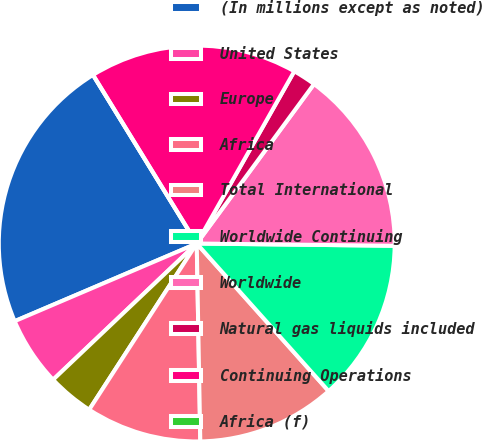<chart> <loc_0><loc_0><loc_500><loc_500><pie_chart><fcel>(In millions except as noted)<fcel>United States<fcel>Europe<fcel>Africa<fcel>Total International<fcel>Worldwide Continuing<fcel>Worldwide<fcel>Natural gas liquids included<fcel>Continuing Operations<fcel>Africa (f)<nl><fcel>22.64%<fcel>5.66%<fcel>3.78%<fcel>9.43%<fcel>11.32%<fcel>13.21%<fcel>15.09%<fcel>1.89%<fcel>16.98%<fcel>0.0%<nl></chart> 